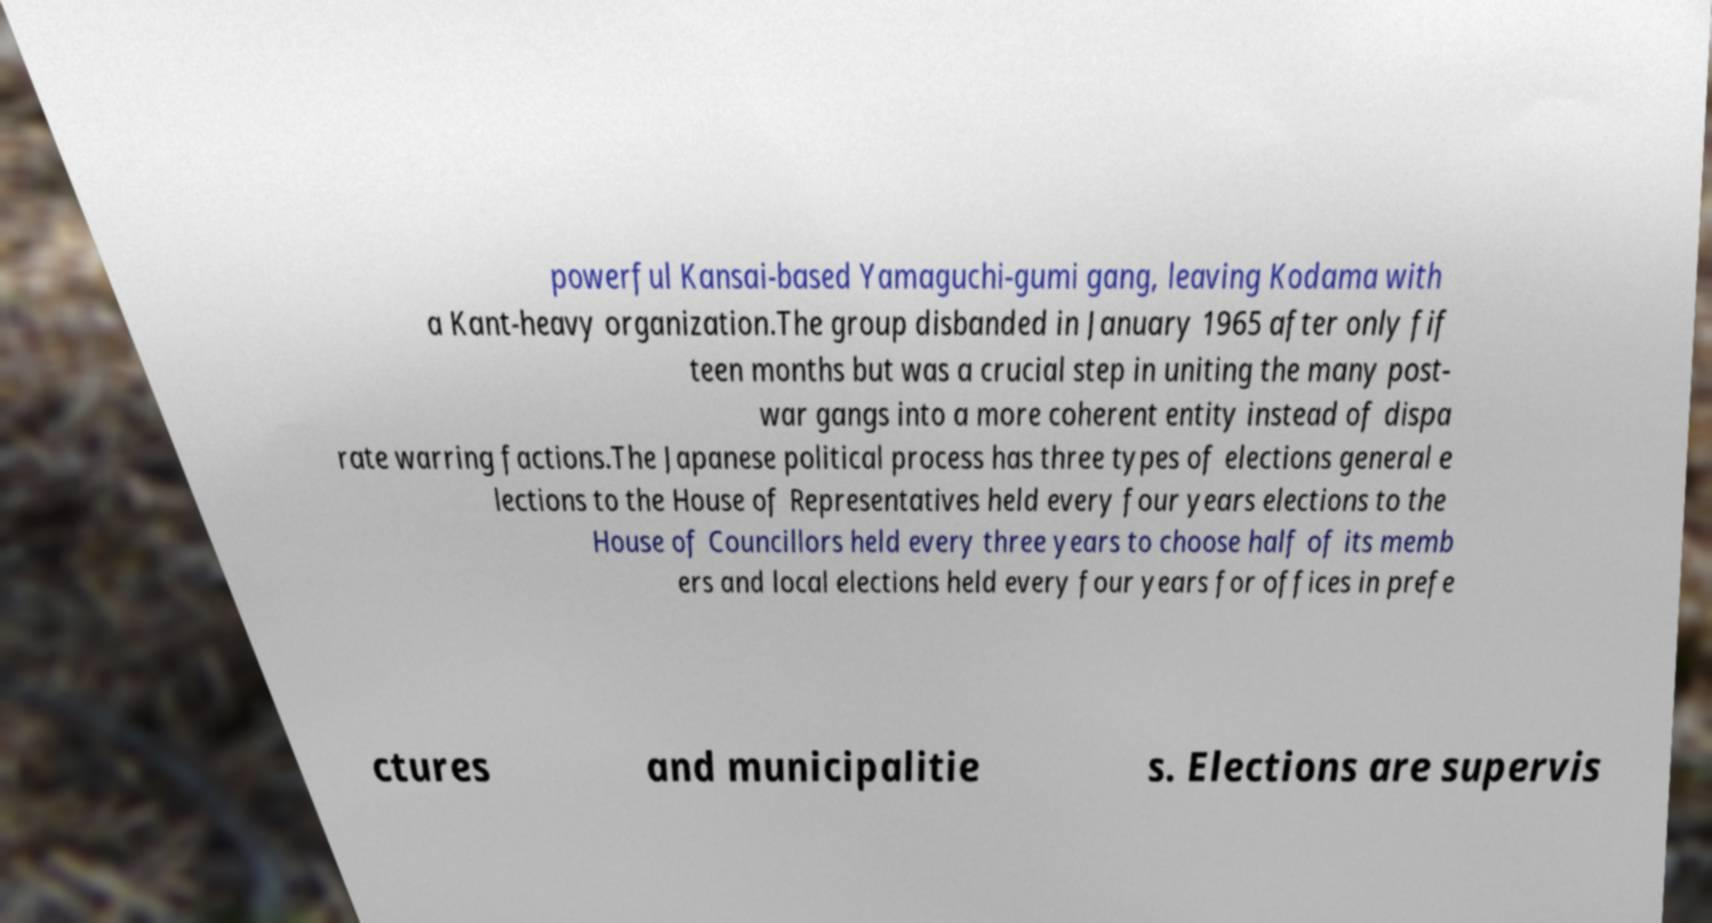Can you read and provide the text displayed in the image?This photo seems to have some interesting text. Can you extract and type it out for me? powerful Kansai-based Yamaguchi-gumi gang, leaving Kodama with a Kant-heavy organization.The group disbanded in January 1965 after only fif teen months but was a crucial step in uniting the many post- war gangs into a more coherent entity instead of dispa rate warring factions.The Japanese political process has three types of elections general e lections to the House of Representatives held every four years elections to the House of Councillors held every three years to choose half of its memb ers and local elections held every four years for offices in prefe ctures and municipalitie s. Elections are supervis 